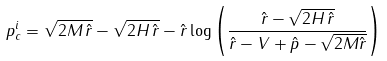Convert formula to latex. <formula><loc_0><loc_0><loc_500><loc_500>p _ { c } ^ { i } = \sqrt { 2 M \, \hat { r } } - \sqrt { 2 H \, \hat { r } } - \hat { r } \log \left ( \frac { \hat { r } - \sqrt { 2 H \, \hat { r } } } { \hat { r } - V + \hat { p } - \sqrt { 2 M \hat { r } } } \right )</formula> 